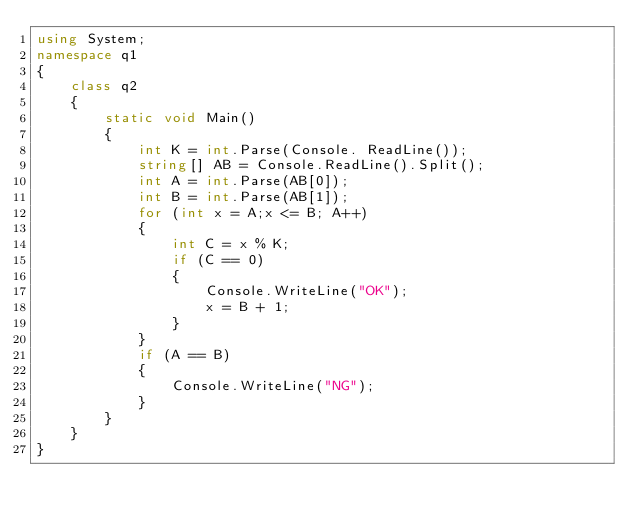Convert code to text. <code><loc_0><loc_0><loc_500><loc_500><_C#_>using System;
namespace q1
{
    class q2
    {
        static void Main()
        {
            int K = int.Parse(Console. ReadLine());
            string[] AB = Console.ReadLine().Split();
            int A = int.Parse(AB[0]);
            int B = int.Parse(AB[1]);
            for (int x = A;x <= B; A++)
            {
                int C = x % K;
                if (C == 0)
                {
                    Console.WriteLine("OK");
                    x = B + 1;
                }
            }
            if (A == B)
            {
                Console.WriteLine("NG");
            }
        }
    }
}
</code> 